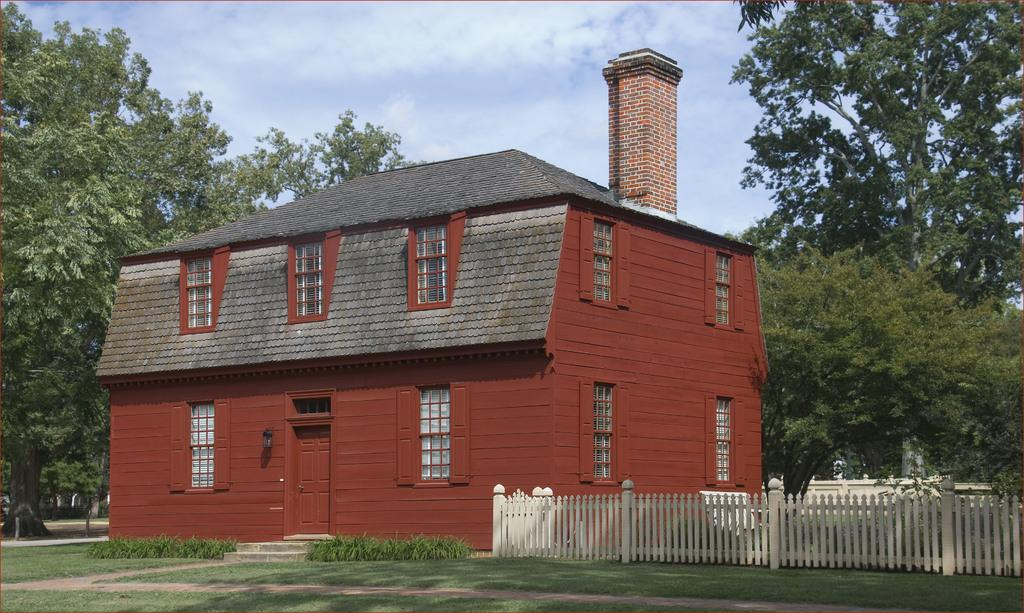What type of vegetation is present in the image? There is grass, trees, and plants in the image. What type of structure can be seen in the image? There is a building with windows in the image. What feature of the building is mentioned in the facts? There is a door on the building. What can be seen in the background of the image? The sky is visible in the background of the image, and there are clouds in the sky. What type of meal is being prepared in the image? There is no indication of a meal being prepared in the image. Can you see any deer in the image? There are no deer present in the image. 